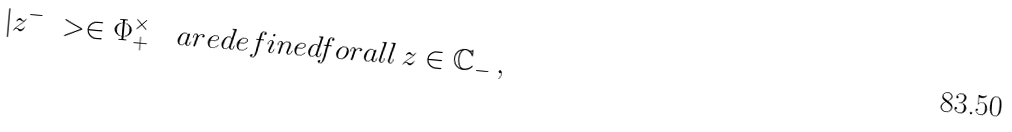<formula> <loc_0><loc_0><loc_500><loc_500>| z ^ { - } \ > \in \Phi ^ { \times } _ { + } \quad a r e d e f i n e d f o r a l l \, z \in \mathbb { C } _ { - } \, ,</formula> 